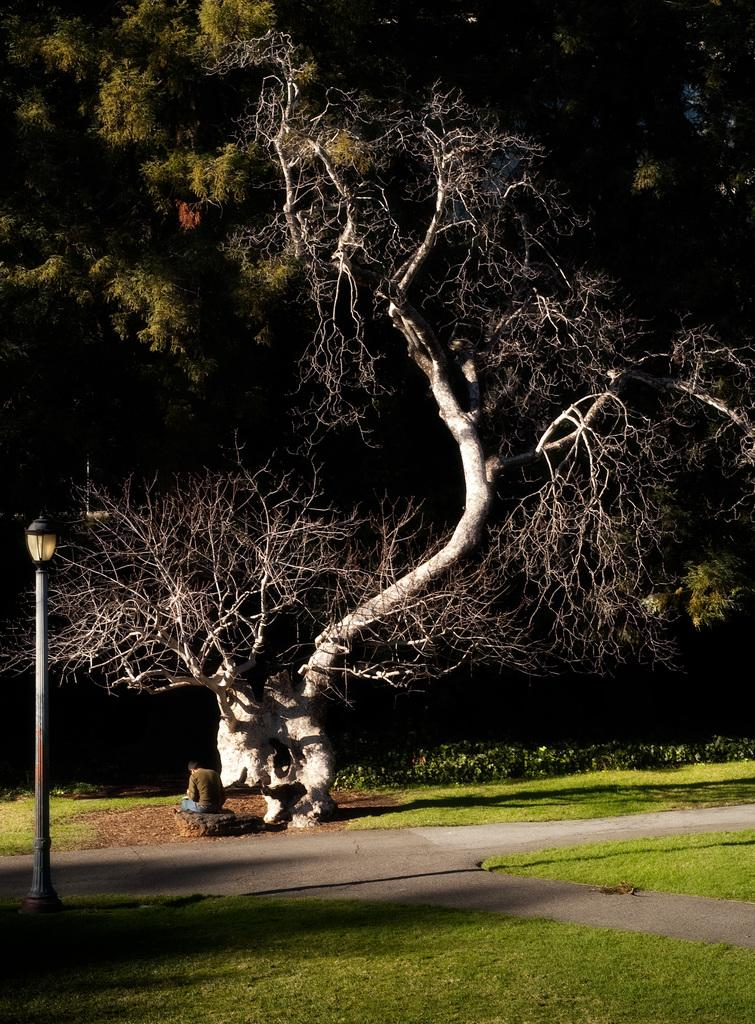What is the person in the image doing? There is a person sitting in the image. What can be seen attached to the pole in the image? There is a lamp attached to the pole in the image. What type of vegetation is present in the image? There is grass in the image. What kind of surface is visible in the image? There is a path in the image. What type of plant is present in the image? There is a tree in the image. What type of cabbage is being used as a mask by the person in the image? There is no cabbage or mask present in the image; the person is simply sitting. Can you tell me how many fish are swimming in the grass in the image? There are no fish present in the image; it features a person sitting, a pole with a lamp, grass, a path, and a tree. 